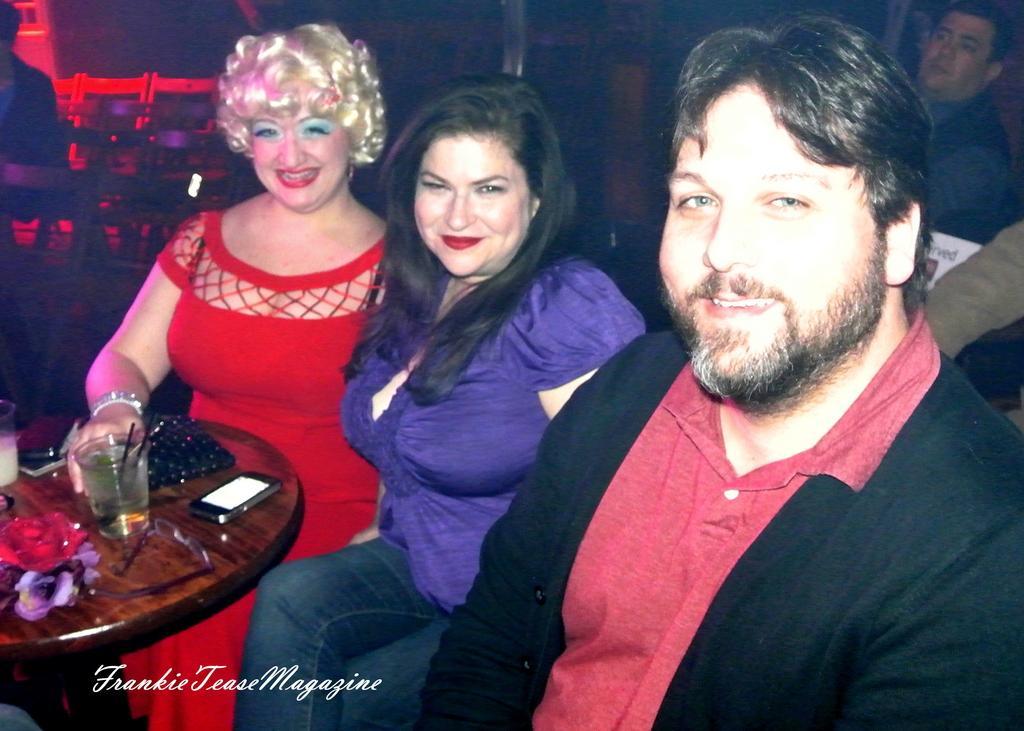Please provide a concise description of this image. In this image we can see two ladies and one man sitting. We can see glass, spectacles, mobile phone, wallet and some things are placed on table. 